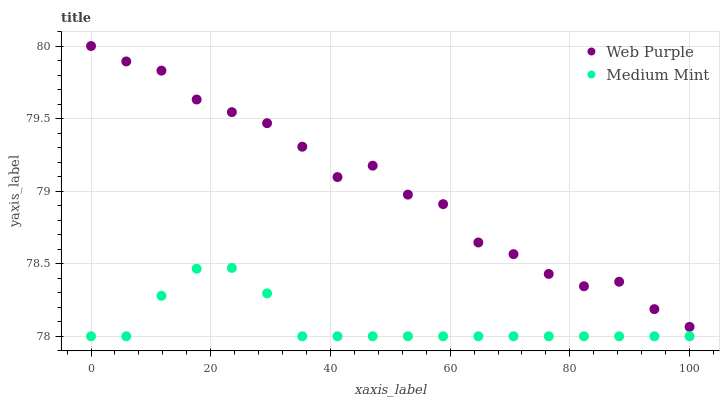Does Medium Mint have the minimum area under the curve?
Answer yes or no. Yes. Does Web Purple have the maximum area under the curve?
Answer yes or no. Yes. Does Web Purple have the minimum area under the curve?
Answer yes or no. No. Is Medium Mint the smoothest?
Answer yes or no. Yes. Is Web Purple the roughest?
Answer yes or no. Yes. Is Web Purple the smoothest?
Answer yes or no. No. Does Medium Mint have the lowest value?
Answer yes or no. Yes. Does Web Purple have the lowest value?
Answer yes or no. No. Does Web Purple have the highest value?
Answer yes or no. Yes. Is Medium Mint less than Web Purple?
Answer yes or no. Yes. Is Web Purple greater than Medium Mint?
Answer yes or no. Yes. Does Medium Mint intersect Web Purple?
Answer yes or no. No. 